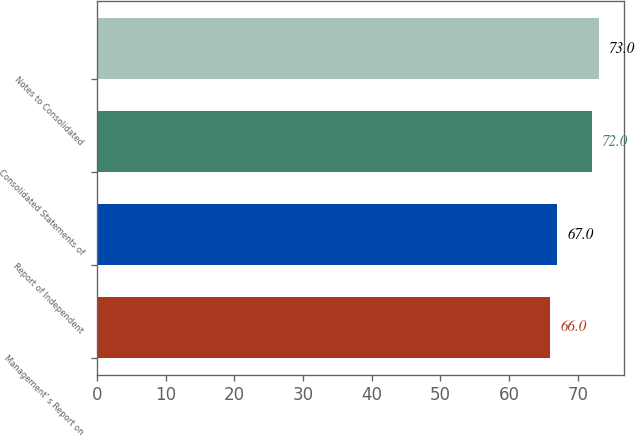Convert chart. <chart><loc_0><loc_0><loc_500><loc_500><bar_chart><fcel>Management' s Report on<fcel>Report of Independent<fcel>Consolidated Statements of<fcel>Notes to Consolidated<nl><fcel>66<fcel>67<fcel>72<fcel>73<nl></chart> 